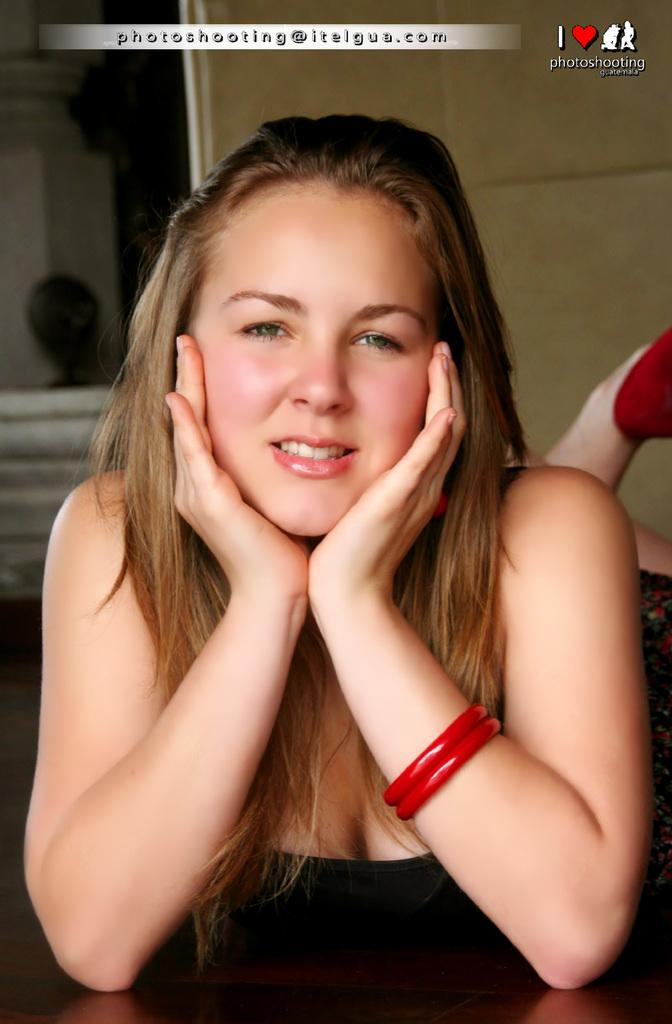What is the girl in the image doing? The girl is sitting on a chair in the image. What is in front of the girl? There is a table in front of the girl. What can be seen in the background of the image? There is a wall in the background of the image. What is at the top of the image? There is text and a logo at the top of the image. What type of jewel is the girl holding in the image? There is no jewel present in the image; the girl is simply sitting on a chair with a table in front of her. 